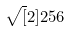Convert formula to latex. <formula><loc_0><loc_0><loc_500><loc_500>\sqrt { [ } 2 ] { 2 5 6 }</formula> 